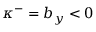<formula> <loc_0><loc_0><loc_500><loc_500>\kappa ^ { - } = b _ { y } < 0</formula> 